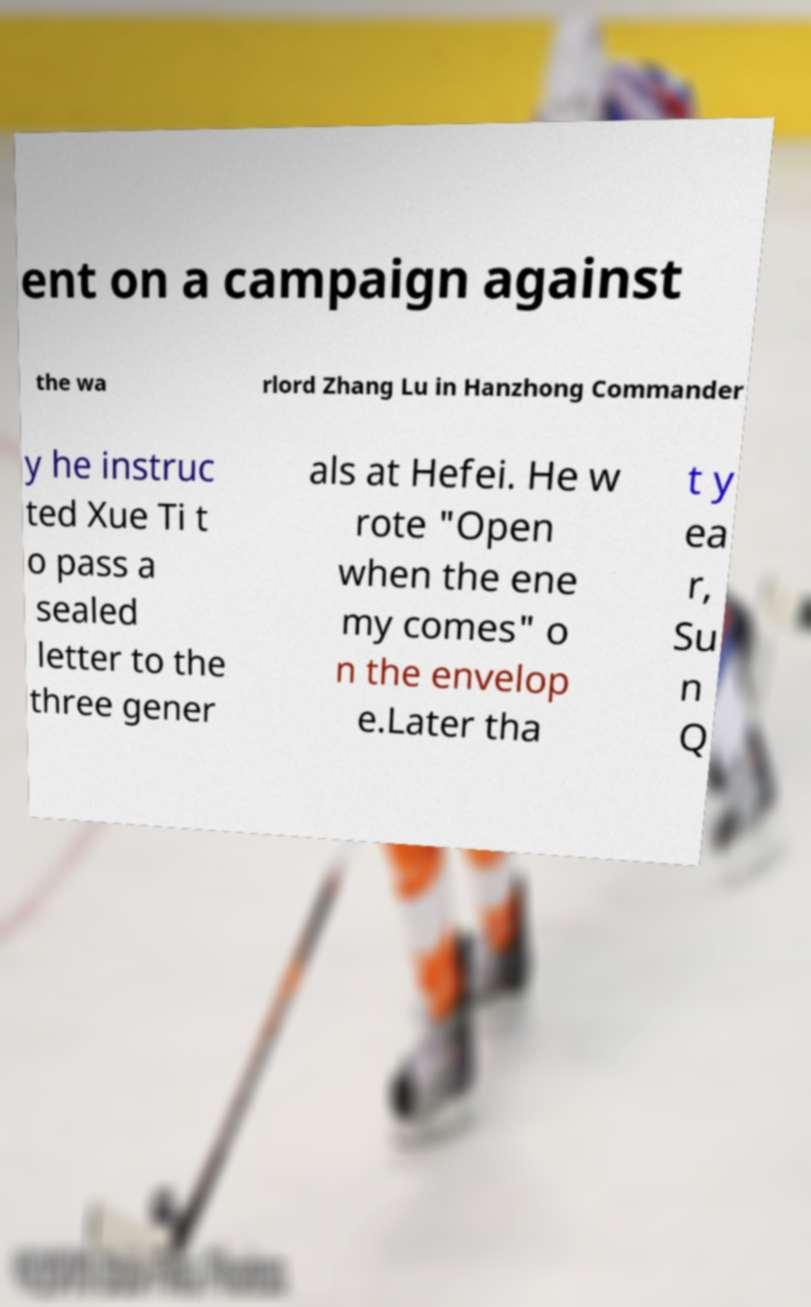For documentation purposes, I need the text within this image transcribed. Could you provide that? ent on a campaign against the wa rlord Zhang Lu in Hanzhong Commander y he instruc ted Xue Ti t o pass a sealed letter to the three gener als at Hefei. He w rote "Open when the ene my comes" o n the envelop e.Later tha t y ea r, Su n Q 